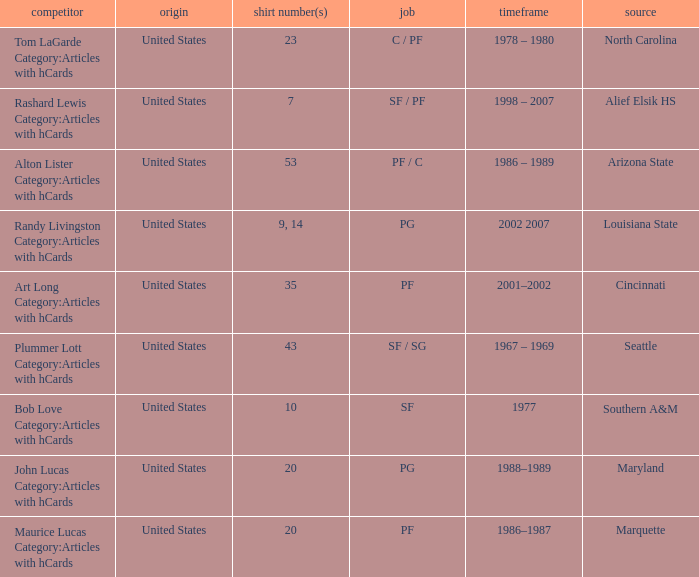Alton Lister Category:Articles with hCards has what as the listed years? 1986 – 1989. 